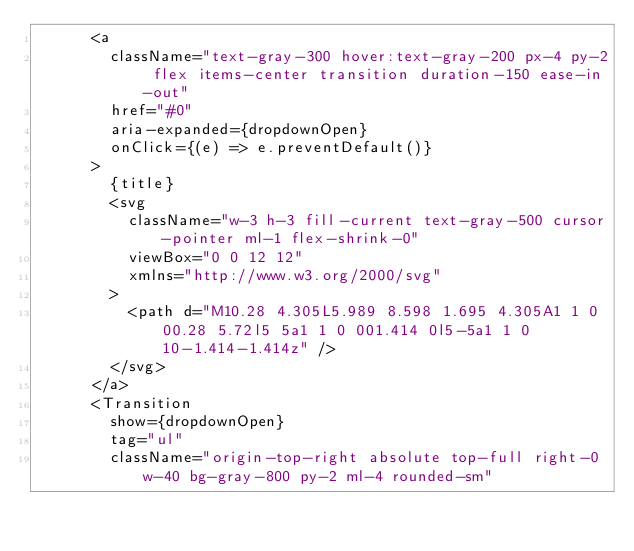<code> <loc_0><loc_0><loc_500><loc_500><_JavaScript_>      <a
        className="text-gray-300 hover:text-gray-200 px-4 py-2 flex items-center transition duration-150 ease-in-out"
        href="#0"
        aria-expanded={dropdownOpen}
        onClick={(e) => e.preventDefault()}
      >
        {title}
        <svg
          className="w-3 h-3 fill-current text-gray-500 cursor-pointer ml-1 flex-shrink-0"
          viewBox="0 0 12 12"
          xmlns="http://www.w3.org/2000/svg"
        >
          <path d="M10.28 4.305L5.989 8.598 1.695 4.305A1 1 0 00.28 5.72l5 5a1 1 0 001.414 0l5-5a1 1 0 10-1.414-1.414z" />
        </svg>
      </a>
      <Transition
        show={dropdownOpen}
        tag="ul"
        className="origin-top-right absolute top-full right-0 w-40 bg-gray-800 py-2 ml-4 rounded-sm"</code> 